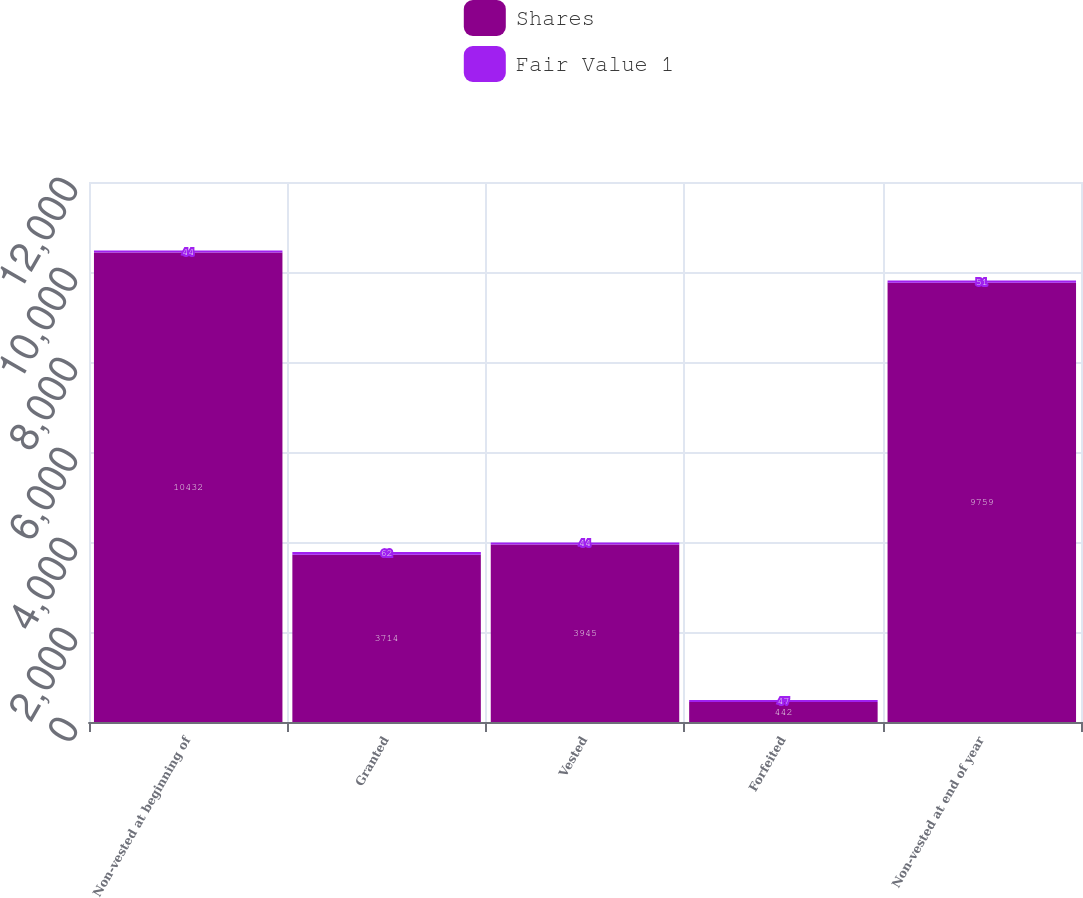<chart> <loc_0><loc_0><loc_500><loc_500><stacked_bar_chart><ecel><fcel>Non-vested at beginning of<fcel>Granted<fcel>Vested<fcel>Forfeited<fcel>Non-vested at end of year<nl><fcel>Shares<fcel>10432<fcel>3714<fcel>3945<fcel>442<fcel>9759<nl><fcel>Fair Value 1<fcel>44<fcel>62<fcel>44<fcel>47<fcel>51<nl></chart> 